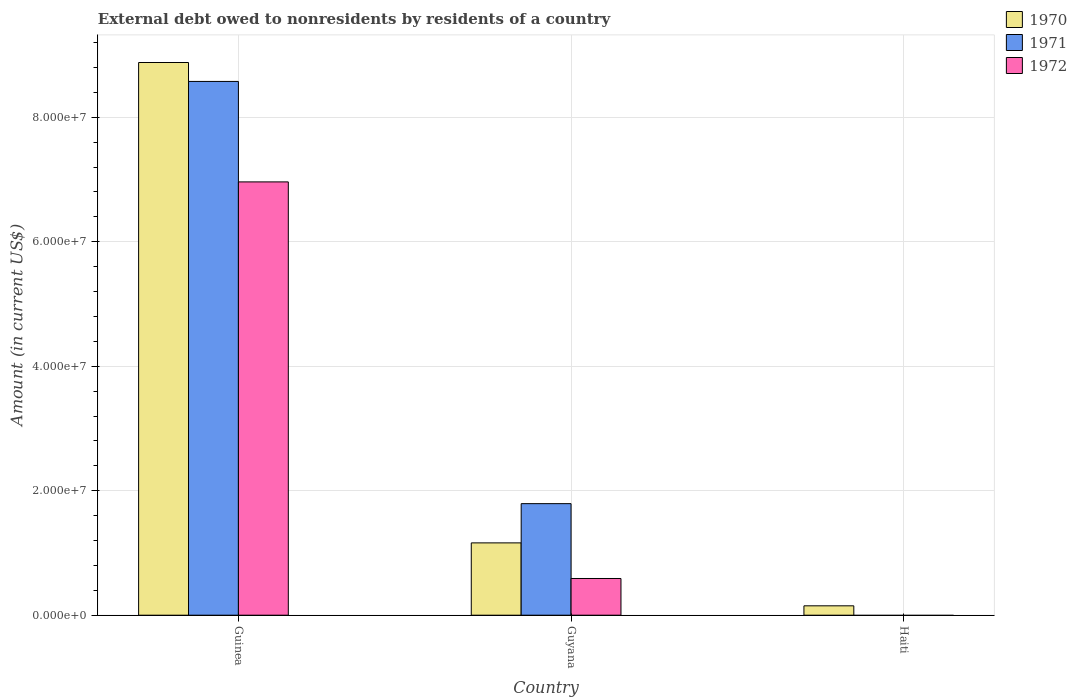Are the number of bars on each tick of the X-axis equal?
Give a very brief answer. No. How many bars are there on the 2nd tick from the right?
Offer a terse response. 3. What is the label of the 1st group of bars from the left?
Your answer should be compact. Guinea. In how many cases, is the number of bars for a given country not equal to the number of legend labels?
Offer a very short reply. 1. What is the external debt owed by residents in 1972 in Guyana?
Provide a succinct answer. 5.90e+06. Across all countries, what is the maximum external debt owed by residents in 1970?
Ensure brevity in your answer.  8.88e+07. In which country was the external debt owed by residents in 1970 maximum?
Provide a short and direct response. Guinea. What is the total external debt owed by residents in 1971 in the graph?
Ensure brevity in your answer.  1.04e+08. What is the difference between the external debt owed by residents in 1970 in Guinea and that in Guyana?
Your answer should be very brief. 7.72e+07. What is the difference between the external debt owed by residents in 1971 in Guyana and the external debt owed by residents in 1970 in Haiti?
Make the answer very short. 1.64e+07. What is the average external debt owed by residents in 1970 per country?
Ensure brevity in your answer.  3.40e+07. What is the difference between the external debt owed by residents of/in 1972 and external debt owed by residents of/in 1971 in Guyana?
Your response must be concise. -1.20e+07. What is the ratio of the external debt owed by residents in 1970 in Guinea to that in Haiti?
Provide a succinct answer. 58.92. Is the difference between the external debt owed by residents in 1972 in Guinea and Guyana greater than the difference between the external debt owed by residents in 1971 in Guinea and Guyana?
Give a very brief answer. No. What is the difference between the highest and the second highest external debt owed by residents in 1970?
Your answer should be very brief. 8.73e+07. What is the difference between the highest and the lowest external debt owed by residents in 1972?
Provide a succinct answer. 6.96e+07. In how many countries, is the external debt owed by residents in 1970 greater than the average external debt owed by residents in 1970 taken over all countries?
Provide a short and direct response. 1. Is the sum of the external debt owed by residents in 1971 in Guinea and Guyana greater than the maximum external debt owed by residents in 1970 across all countries?
Provide a short and direct response. Yes. Is it the case that in every country, the sum of the external debt owed by residents in 1972 and external debt owed by residents in 1971 is greater than the external debt owed by residents in 1970?
Provide a short and direct response. No. Are all the bars in the graph horizontal?
Provide a succinct answer. No. Does the graph contain grids?
Offer a terse response. Yes. How are the legend labels stacked?
Provide a succinct answer. Vertical. What is the title of the graph?
Your response must be concise. External debt owed to nonresidents by residents of a country. What is the label or title of the X-axis?
Your answer should be compact. Country. What is the Amount (in current US$) in 1970 in Guinea?
Ensure brevity in your answer.  8.88e+07. What is the Amount (in current US$) in 1971 in Guinea?
Ensure brevity in your answer.  8.58e+07. What is the Amount (in current US$) in 1972 in Guinea?
Provide a succinct answer. 6.96e+07. What is the Amount (in current US$) of 1970 in Guyana?
Your response must be concise. 1.16e+07. What is the Amount (in current US$) in 1971 in Guyana?
Provide a succinct answer. 1.79e+07. What is the Amount (in current US$) of 1972 in Guyana?
Your answer should be very brief. 5.90e+06. What is the Amount (in current US$) in 1970 in Haiti?
Your answer should be compact. 1.51e+06. What is the Amount (in current US$) of 1971 in Haiti?
Offer a terse response. 0. What is the Amount (in current US$) of 1972 in Haiti?
Keep it short and to the point. 0. Across all countries, what is the maximum Amount (in current US$) of 1970?
Your response must be concise. 8.88e+07. Across all countries, what is the maximum Amount (in current US$) of 1971?
Make the answer very short. 8.58e+07. Across all countries, what is the maximum Amount (in current US$) of 1972?
Give a very brief answer. 6.96e+07. Across all countries, what is the minimum Amount (in current US$) in 1970?
Provide a short and direct response. 1.51e+06. Across all countries, what is the minimum Amount (in current US$) of 1971?
Make the answer very short. 0. Across all countries, what is the minimum Amount (in current US$) in 1972?
Give a very brief answer. 0. What is the total Amount (in current US$) of 1970 in the graph?
Your answer should be compact. 1.02e+08. What is the total Amount (in current US$) of 1971 in the graph?
Give a very brief answer. 1.04e+08. What is the total Amount (in current US$) of 1972 in the graph?
Offer a terse response. 7.55e+07. What is the difference between the Amount (in current US$) in 1970 in Guinea and that in Guyana?
Make the answer very short. 7.72e+07. What is the difference between the Amount (in current US$) in 1971 in Guinea and that in Guyana?
Provide a short and direct response. 6.78e+07. What is the difference between the Amount (in current US$) of 1972 in Guinea and that in Guyana?
Offer a terse response. 6.37e+07. What is the difference between the Amount (in current US$) of 1970 in Guinea and that in Haiti?
Keep it short and to the point. 8.73e+07. What is the difference between the Amount (in current US$) in 1970 in Guyana and that in Haiti?
Offer a very short reply. 1.01e+07. What is the difference between the Amount (in current US$) in 1970 in Guinea and the Amount (in current US$) in 1971 in Guyana?
Offer a very short reply. 7.09e+07. What is the difference between the Amount (in current US$) in 1970 in Guinea and the Amount (in current US$) in 1972 in Guyana?
Make the answer very short. 8.29e+07. What is the difference between the Amount (in current US$) of 1971 in Guinea and the Amount (in current US$) of 1972 in Guyana?
Give a very brief answer. 7.99e+07. What is the average Amount (in current US$) in 1970 per country?
Ensure brevity in your answer.  3.40e+07. What is the average Amount (in current US$) of 1971 per country?
Your answer should be very brief. 3.46e+07. What is the average Amount (in current US$) in 1972 per country?
Give a very brief answer. 2.52e+07. What is the difference between the Amount (in current US$) of 1970 and Amount (in current US$) of 1971 in Guinea?
Make the answer very short. 3.04e+06. What is the difference between the Amount (in current US$) of 1970 and Amount (in current US$) of 1972 in Guinea?
Offer a terse response. 1.92e+07. What is the difference between the Amount (in current US$) of 1971 and Amount (in current US$) of 1972 in Guinea?
Offer a terse response. 1.61e+07. What is the difference between the Amount (in current US$) of 1970 and Amount (in current US$) of 1971 in Guyana?
Provide a succinct answer. -6.30e+06. What is the difference between the Amount (in current US$) in 1970 and Amount (in current US$) in 1972 in Guyana?
Offer a very short reply. 5.72e+06. What is the difference between the Amount (in current US$) in 1971 and Amount (in current US$) in 1972 in Guyana?
Offer a very short reply. 1.20e+07. What is the ratio of the Amount (in current US$) in 1970 in Guinea to that in Guyana?
Offer a terse response. 7.64. What is the ratio of the Amount (in current US$) of 1971 in Guinea to that in Guyana?
Your answer should be compact. 4.79. What is the ratio of the Amount (in current US$) of 1972 in Guinea to that in Guyana?
Offer a very short reply. 11.81. What is the ratio of the Amount (in current US$) of 1970 in Guinea to that in Haiti?
Your answer should be very brief. 58.92. What is the ratio of the Amount (in current US$) of 1970 in Guyana to that in Haiti?
Your answer should be very brief. 7.71. What is the difference between the highest and the second highest Amount (in current US$) in 1970?
Provide a short and direct response. 7.72e+07. What is the difference between the highest and the lowest Amount (in current US$) of 1970?
Make the answer very short. 8.73e+07. What is the difference between the highest and the lowest Amount (in current US$) of 1971?
Ensure brevity in your answer.  8.58e+07. What is the difference between the highest and the lowest Amount (in current US$) of 1972?
Give a very brief answer. 6.96e+07. 